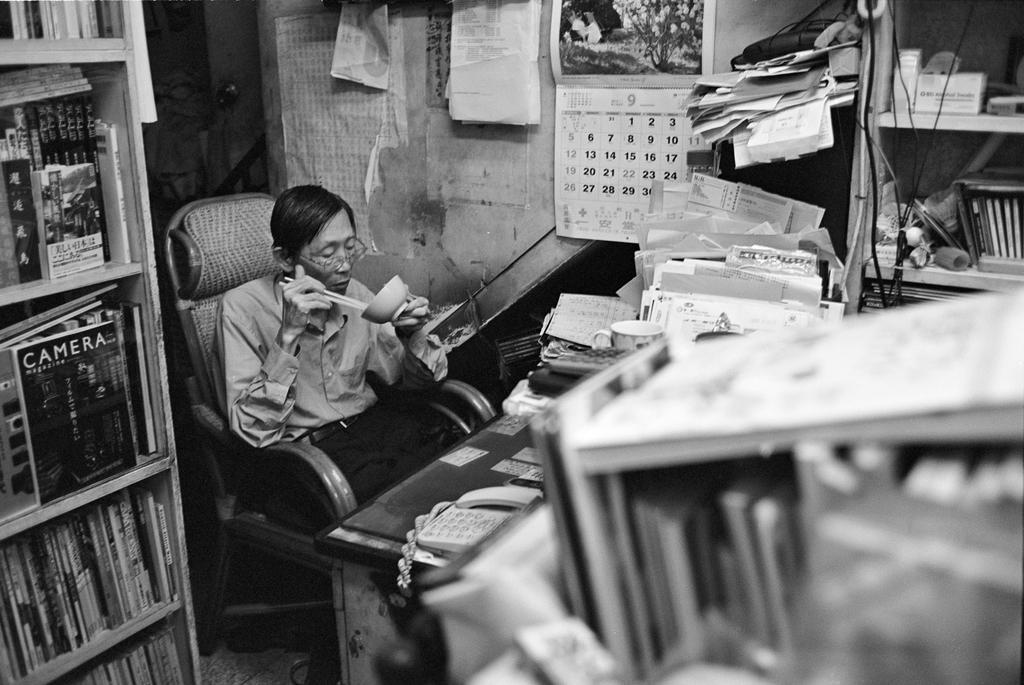What is the person in the image doing? The person is sitting on a chair in the image. Where is the person located? The person is in a room. What is on the table in the image? The table has papers and a telephone on it. What is the purpose of the rocks in the image? The rocks have books on them. Is the person in the image fighting with a clover? There is no clover present in the image, and the person is not fighting with anything. 